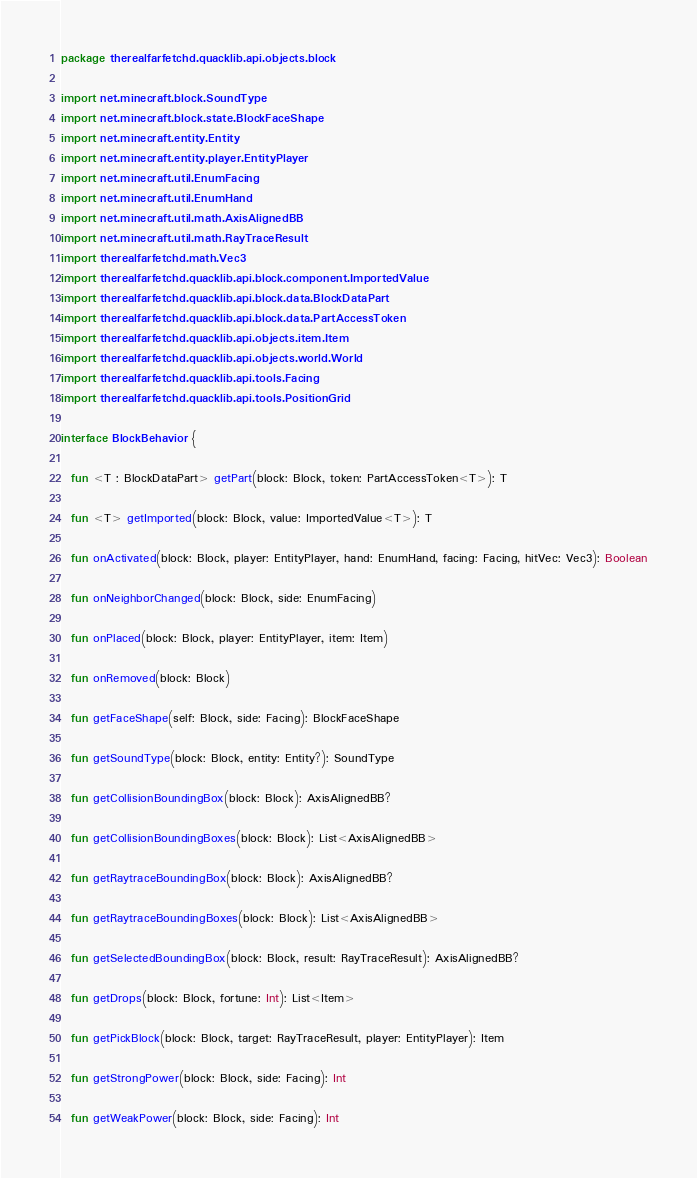<code> <loc_0><loc_0><loc_500><loc_500><_Kotlin_>package therealfarfetchd.quacklib.api.objects.block

import net.minecraft.block.SoundType
import net.minecraft.block.state.BlockFaceShape
import net.minecraft.entity.Entity
import net.minecraft.entity.player.EntityPlayer
import net.minecraft.util.EnumFacing
import net.minecraft.util.EnumHand
import net.minecraft.util.math.AxisAlignedBB
import net.minecraft.util.math.RayTraceResult
import therealfarfetchd.math.Vec3
import therealfarfetchd.quacklib.api.block.component.ImportedValue
import therealfarfetchd.quacklib.api.block.data.BlockDataPart
import therealfarfetchd.quacklib.api.block.data.PartAccessToken
import therealfarfetchd.quacklib.api.objects.item.Item
import therealfarfetchd.quacklib.api.objects.world.World
import therealfarfetchd.quacklib.api.tools.Facing
import therealfarfetchd.quacklib.api.tools.PositionGrid

interface BlockBehavior {

  fun <T : BlockDataPart> getPart(block: Block, token: PartAccessToken<T>): T

  fun <T> getImported(block: Block, value: ImportedValue<T>): T

  fun onActivated(block: Block, player: EntityPlayer, hand: EnumHand, facing: Facing, hitVec: Vec3): Boolean

  fun onNeighborChanged(block: Block, side: EnumFacing)

  fun onPlaced(block: Block, player: EntityPlayer, item: Item)

  fun onRemoved(block: Block)

  fun getFaceShape(self: Block, side: Facing): BlockFaceShape

  fun getSoundType(block: Block, entity: Entity?): SoundType

  fun getCollisionBoundingBox(block: Block): AxisAlignedBB?

  fun getCollisionBoundingBoxes(block: Block): List<AxisAlignedBB>

  fun getRaytraceBoundingBox(block: Block): AxisAlignedBB?

  fun getRaytraceBoundingBoxes(block: Block): List<AxisAlignedBB>

  fun getSelectedBoundingBox(block: Block, result: RayTraceResult): AxisAlignedBB?

  fun getDrops(block: Block, fortune: Int): List<Item>

  fun getPickBlock(block: Block, target: RayTraceResult, player: EntityPlayer): Item

  fun getStrongPower(block: Block, side: Facing): Int

  fun getWeakPower(block: Block, side: Facing): Int
</code> 